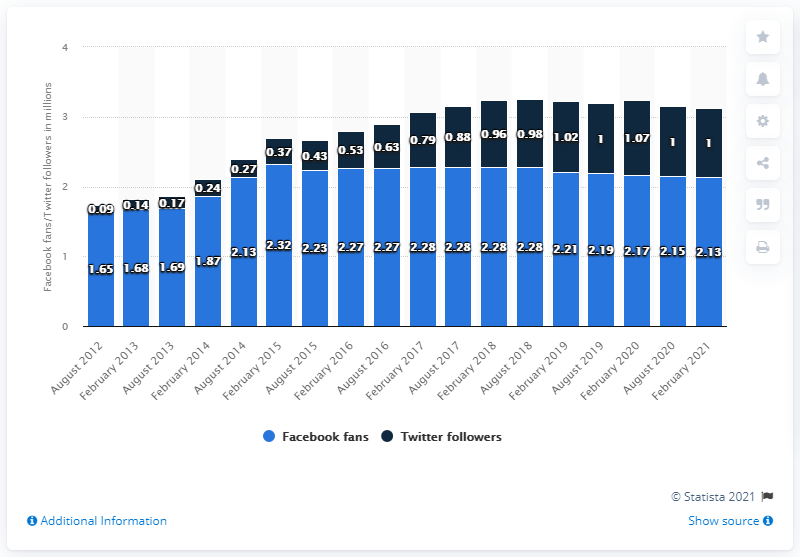Specify some key components in this picture. The Indianapolis Colts football team had 2.13 million Facebook followers in February 2021. 